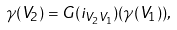Convert formula to latex. <formula><loc_0><loc_0><loc_500><loc_500>\gamma ( V _ { 2 } ) = { G } ( i _ { V _ { 2 } V _ { 1 } } ) ( \gamma ( V _ { 1 } ) ) ,</formula> 